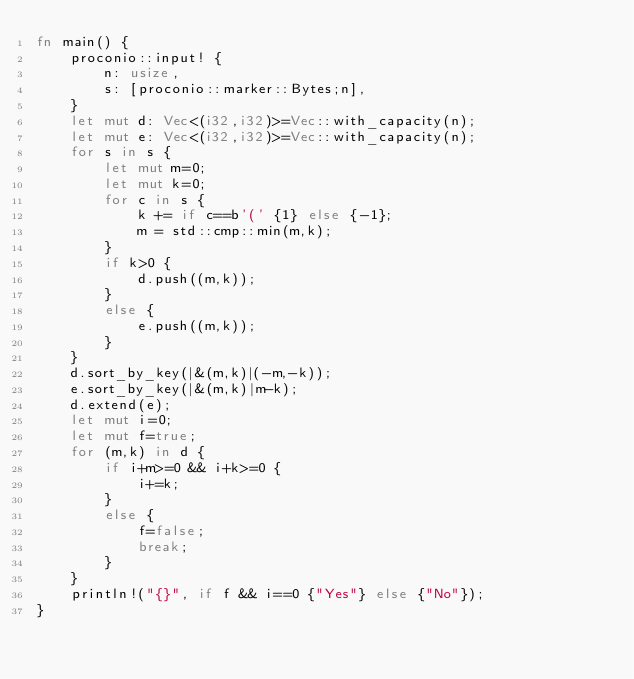<code> <loc_0><loc_0><loc_500><loc_500><_Rust_>fn main() {
    proconio::input! {
        n: usize,
        s: [proconio::marker::Bytes;n],
    }
    let mut d: Vec<(i32,i32)>=Vec::with_capacity(n);
    let mut e: Vec<(i32,i32)>=Vec::with_capacity(n);
    for s in s {
        let mut m=0;
        let mut k=0;
        for c in s {
            k += if c==b'(' {1} else {-1};
            m = std::cmp::min(m,k);
        }
        if k>0 {
            d.push((m,k));
        }
        else {
            e.push((m,k));
        }
    }
    d.sort_by_key(|&(m,k)|(-m,-k));
    e.sort_by_key(|&(m,k)|m-k);
    d.extend(e);
    let mut i=0;
    let mut f=true;
    for (m,k) in d {
        if i+m>=0 && i+k>=0 {
            i+=k;
        }
        else {
            f=false;
            break;
        }
    }
    println!("{}", if f && i==0 {"Yes"} else {"No"});
}</code> 